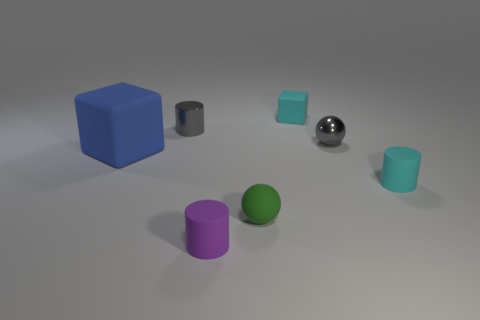How many things are to the right of the purple cylinder and in front of the blue thing?
Offer a very short reply. 2. How many other things are there of the same color as the small matte cube?
Make the answer very short. 1. What is the shape of the thing left of the metal cylinder?
Keep it short and to the point. Cube. Are the purple cylinder and the cyan cylinder made of the same material?
Provide a succinct answer. Yes. Are there any other things that have the same size as the blue block?
Offer a very short reply. No. What number of objects are in front of the gray cylinder?
Ensure brevity in your answer.  5. There is a small gray metal object that is on the left side of the tiny gray shiny thing right of the rubber ball; what is its shape?
Give a very brief answer. Cylinder. Are there more cyan rubber things behind the tiny gray cylinder than tiny red rubber cylinders?
Offer a terse response. Yes. What number of small cyan matte blocks are on the right side of the tiny cyan object that is behind the small gray cylinder?
Offer a terse response. 0. What shape is the cyan matte thing that is behind the cylinder that is on the right side of the tiny matte thing that is behind the big blue object?
Offer a very short reply. Cube. 